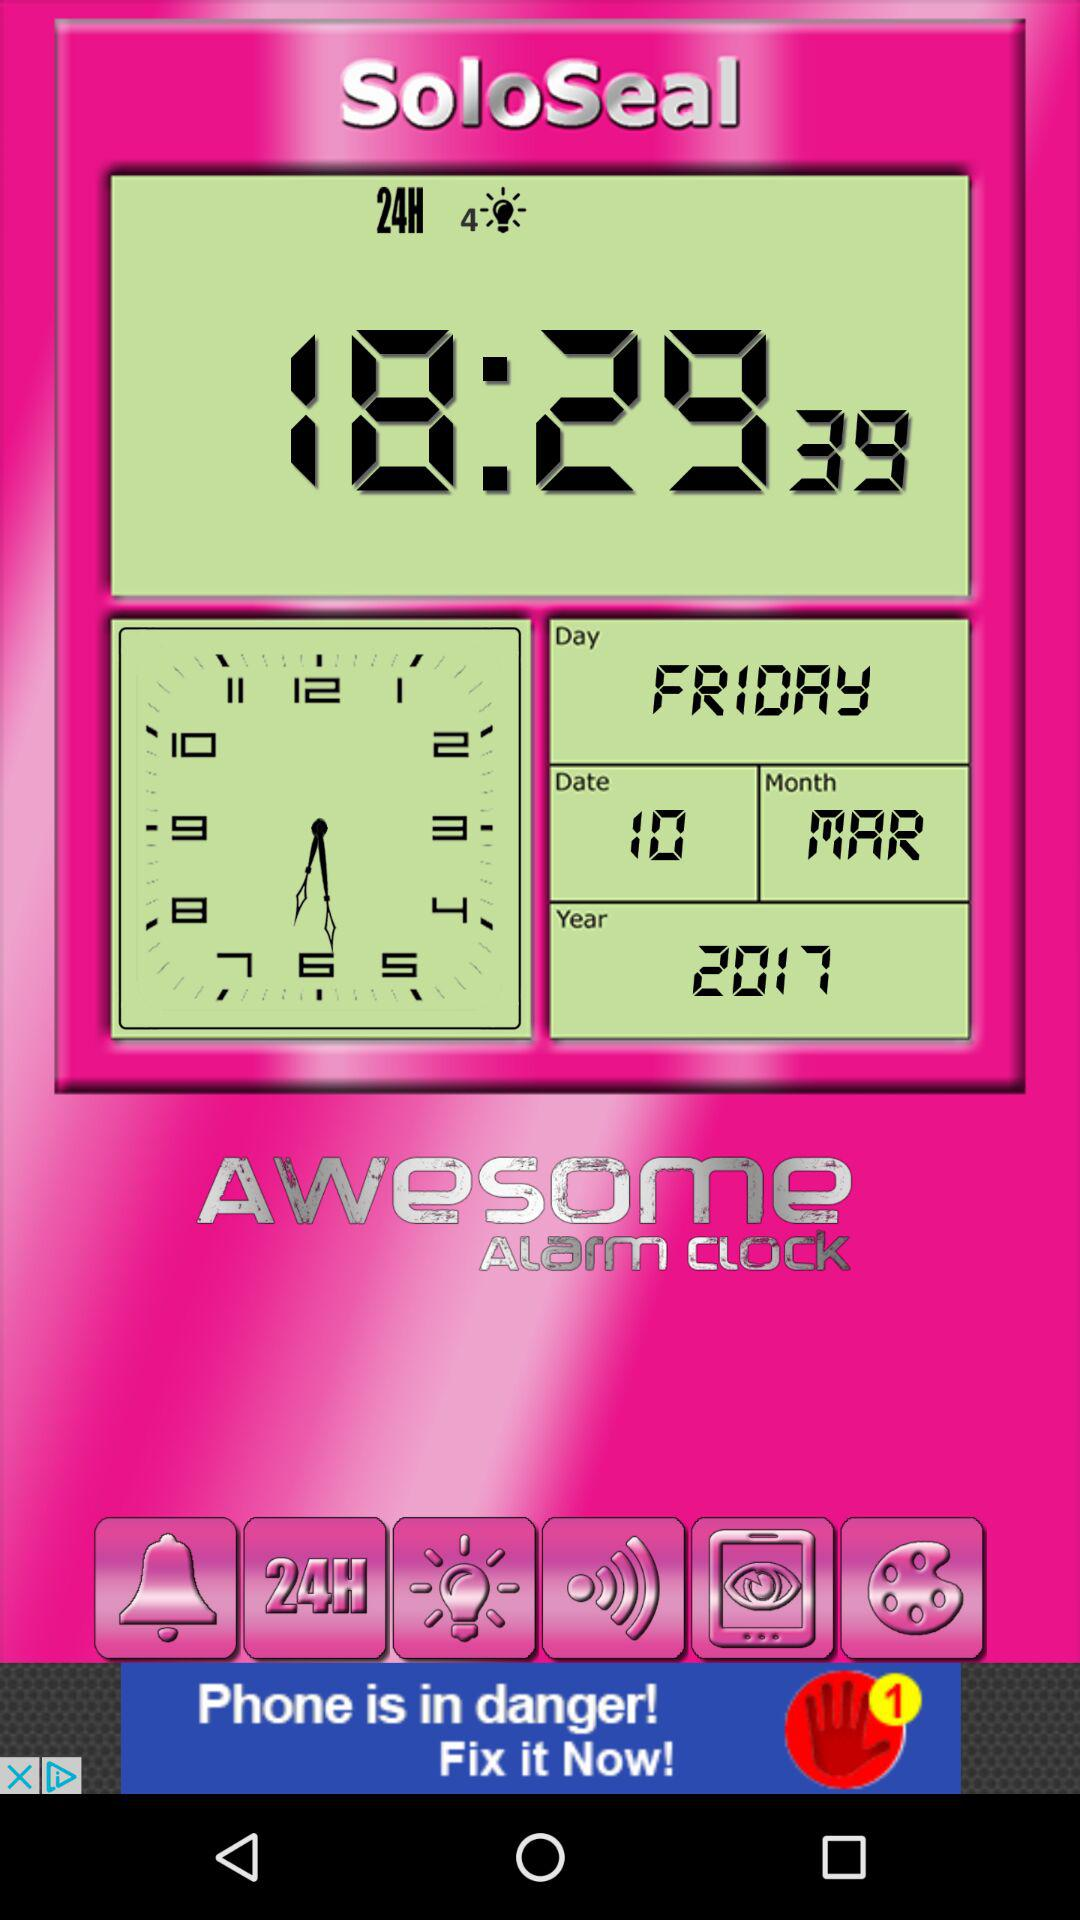What is the date? The date is Friday, March 10, 2017. 